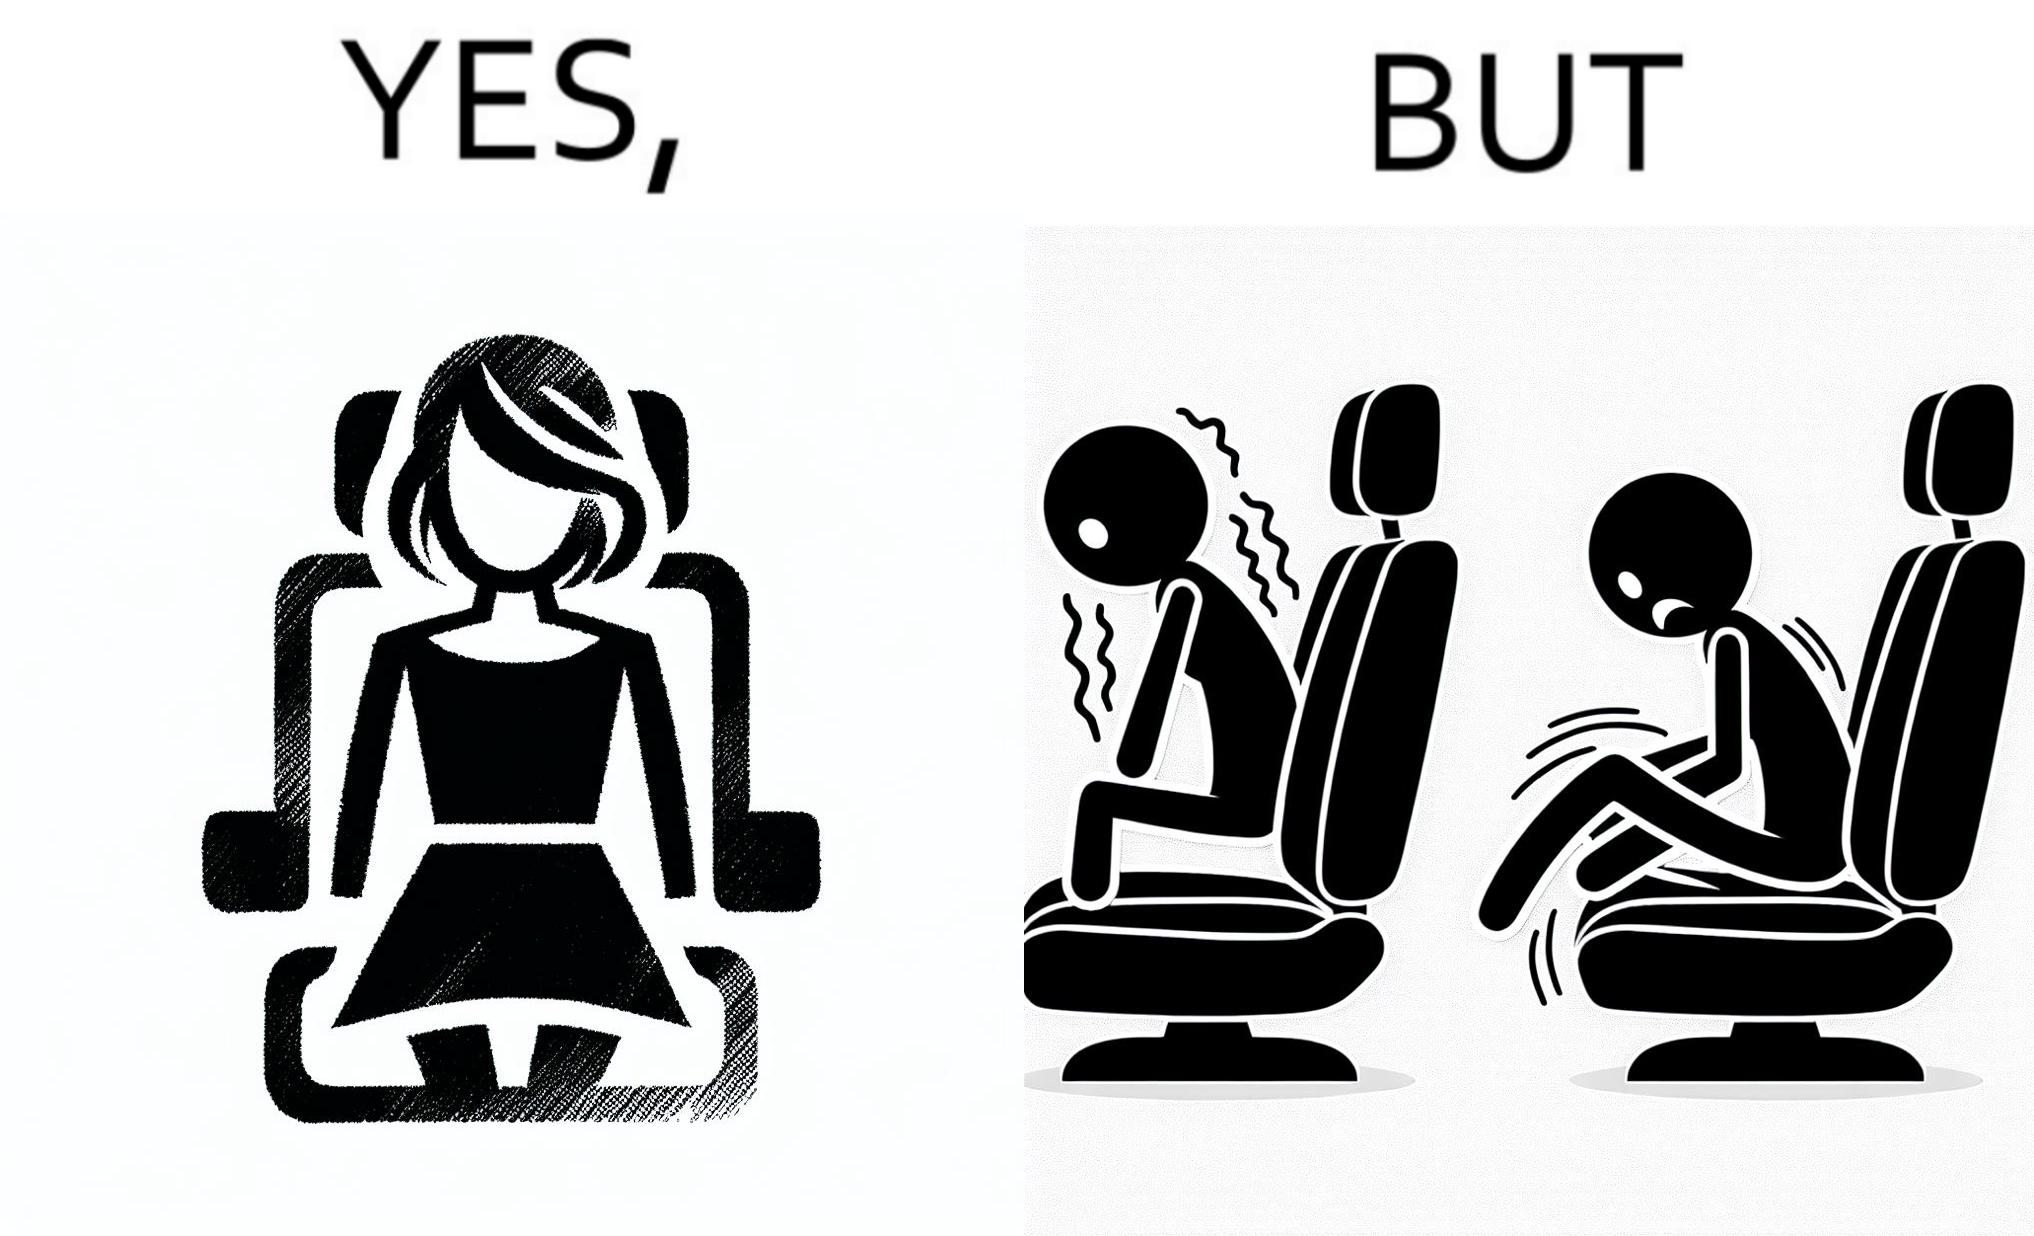Describe the contrast between the left and right parts of this image. In the left part of the image: a woman wearing a short dress sitting on the co-passengers seat in a car In the right part of the image: skin of a woman getting sticked to the seat fabric of the car, causing inconvenience 